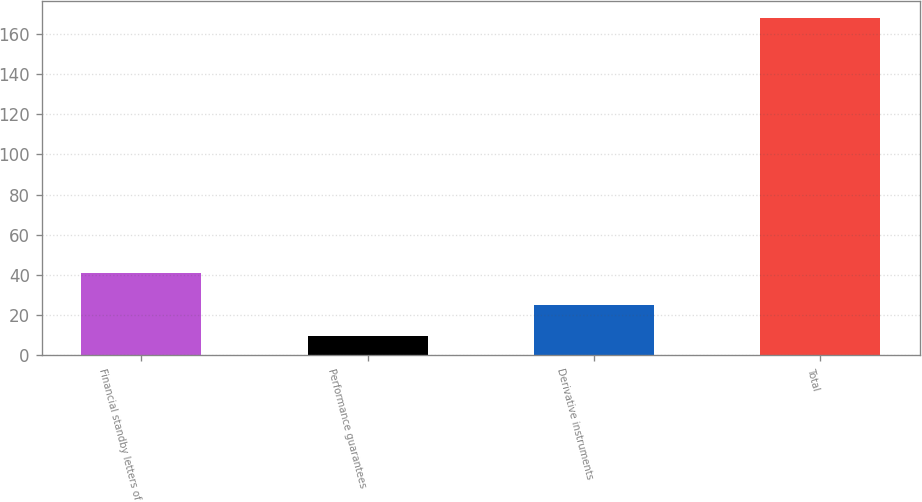Convert chart to OTSL. <chart><loc_0><loc_0><loc_500><loc_500><bar_chart><fcel>Financial standby letters of<fcel>Performance guarantees<fcel>Derivative instruments<fcel>Total<nl><fcel>41.08<fcel>9.4<fcel>25.24<fcel>167.8<nl></chart> 